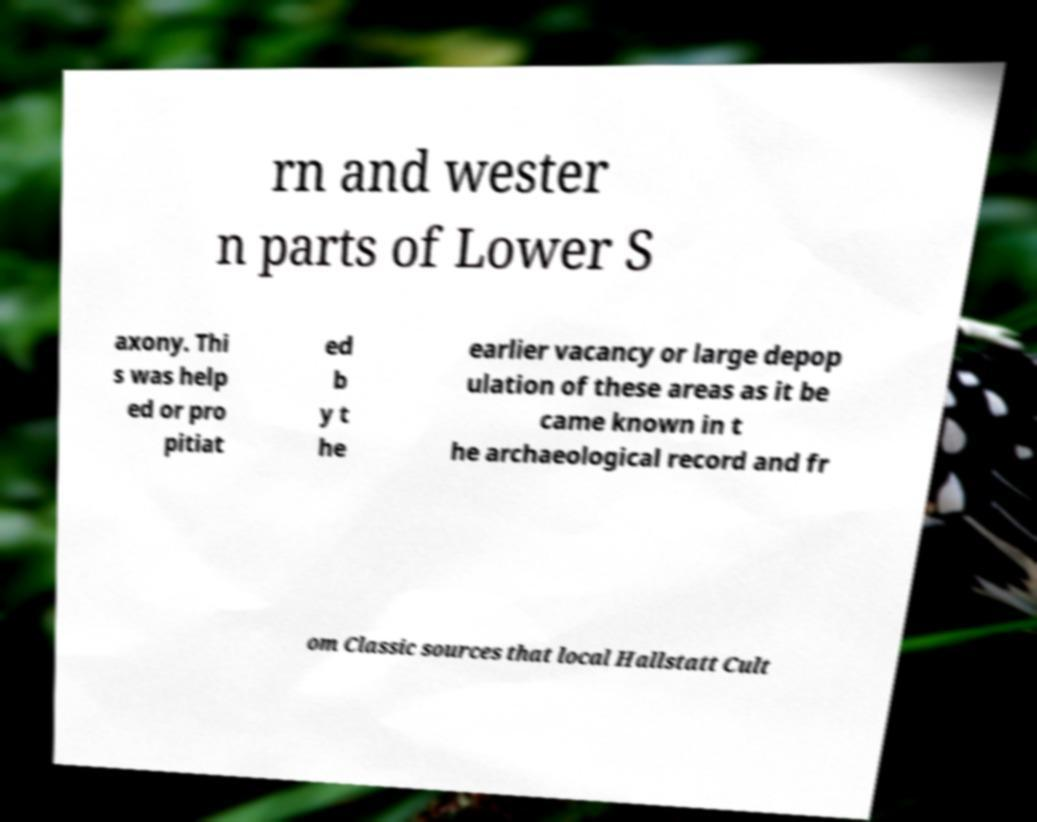Can you accurately transcribe the text from the provided image for me? rn and wester n parts of Lower S axony. Thi s was help ed or pro pitiat ed b y t he earlier vacancy or large depop ulation of these areas as it be came known in t he archaeological record and fr om Classic sources that local Hallstatt Cult 